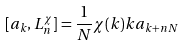Convert formula to latex. <formula><loc_0><loc_0><loc_500><loc_500>[ a _ { k } , L _ { n } ^ { \chi } ] = \frac { 1 } { N } \chi ( k ) k a _ { k + n N }</formula> 